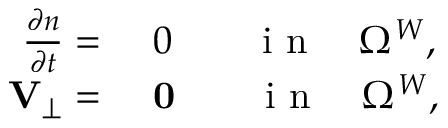Convert formula to latex. <formula><loc_0><loc_0><loc_500><loc_500>\begin{array} { r l } { \frac { \partial n } { \partial t } = } & 0 \quad i n \quad \Omega ^ { W } , } \\ { { \mathbf V } _ { \perp } = } & 0 \quad i n \quad \Omega ^ { W } , } \end{array}</formula> 